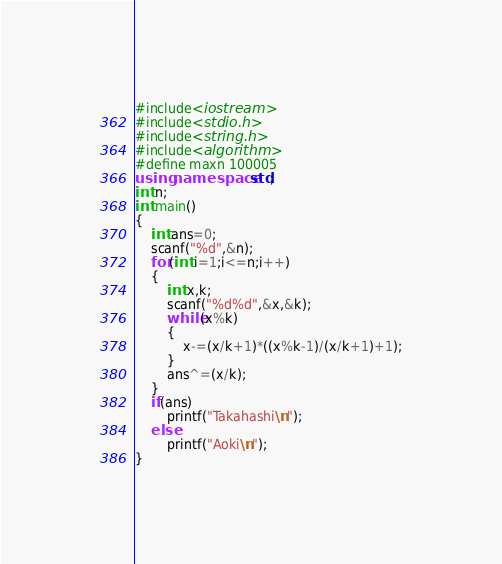<code> <loc_0><loc_0><loc_500><loc_500><_C++_>#include<iostream>
#include<stdio.h>
#include<string.h>
#include<algorithm>
#define maxn 100005
using namespace std;
int n;
int main()
{
	int ans=0;
	scanf("%d",&n);
	for(int i=1;i<=n;i++)
	{
		int x,k;
		scanf("%d%d",&x,&k);
		while(x%k)
		{
			x-=(x/k+1)*((x%k-1)/(x/k+1)+1);
		}
		ans^=(x/k);
	}
	if(ans)
		printf("Takahashi\n");
	else
		printf("Aoki\n");
}
</code> 